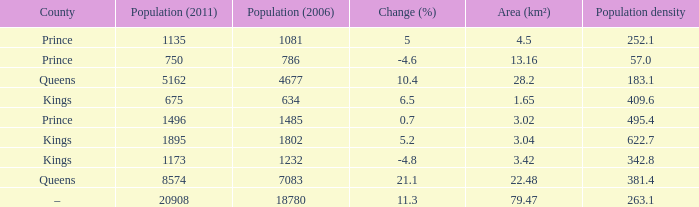4? None. Parse the full table. {'header': ['County', 'Population (2011)', 'Population (2006)', 'Change (%)', 'Area (km²)', 'Population density'], 'rows': [['Prince', '1135', '1081', '5', '4.5', '252.1'], ['Prince', '750', '786', '-4.6', '13.16', '57.0'], ['Queens', '5162', '4677', '10.4', '28.2', '183.1'], ['Kings', '675', '634', '6.5', '1.65', '409.6'], ['Prince', '1496', '1485', '0.7', '3.02', '495.4'], ['Kings', '1895', '1802', '5.2', '3.04', '622.7'], ['Kings', '1173', '1232', '-4.8', '3.42', '342.8'], ['Queens', '8574', '7083', '21.1', '22.48', '381.4'], ['–', '20908', '18780', '11.3', '79.47', '263.1']]} 